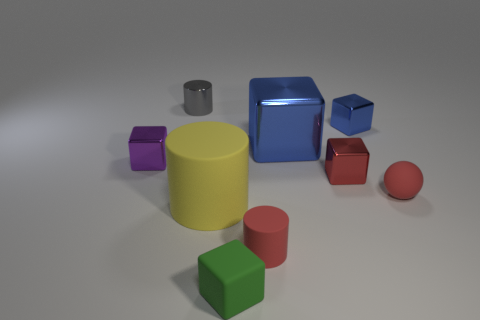Subtract all large blue metal cubes. How many cubes are left? 4 Subtract all yellow cubes. Subtract all yellow cylinders. How many cubes are left? 5 Add 1 large yellow things. How many objects exist? 10 Subtract all cylinders. How many objects are left? 6 Subtract all big yellow rubber objects. Subtract all tiny red rubber objects. How many objects are left? 6 Add 4 red matte balls. How many red matte balls are left? 5 Add 6 green rubber objects. How many green rubber objects exist? 7 Subtract 1 red balls. How many objects are left? 8 